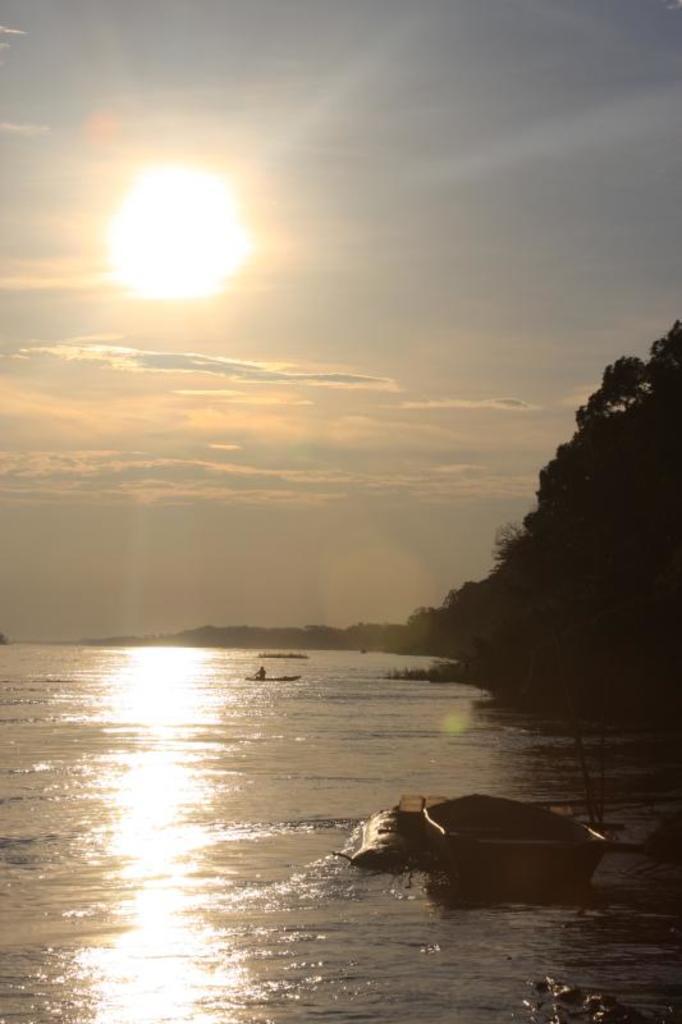Please provide a concise description of this image. In this picture we can see boats on water, trees and in the background we can see the sky with clouds. 